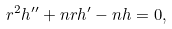<formula> <loc_0><loc_0><loc_500><loc_500>r ^ { 2 } h ^ { \prime \prime } + n r h ^ { \prime } - n h = 0 ,</formula> 